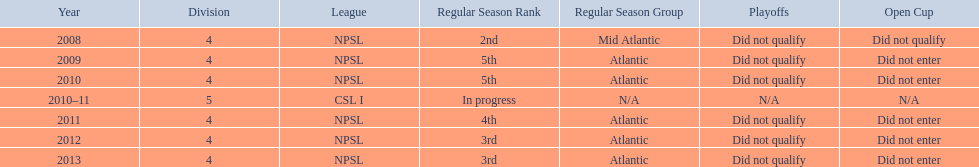What was the last year they were 5th? 2010. 